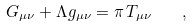Convert formula to latex. <formula><loc_0><loc_0><loc_500><loc_500>G _ { \mu \nu } + \Lambda g _ { \mu \nu } = \pi \, T _ { \mu \nu } \quad ,</formula> 